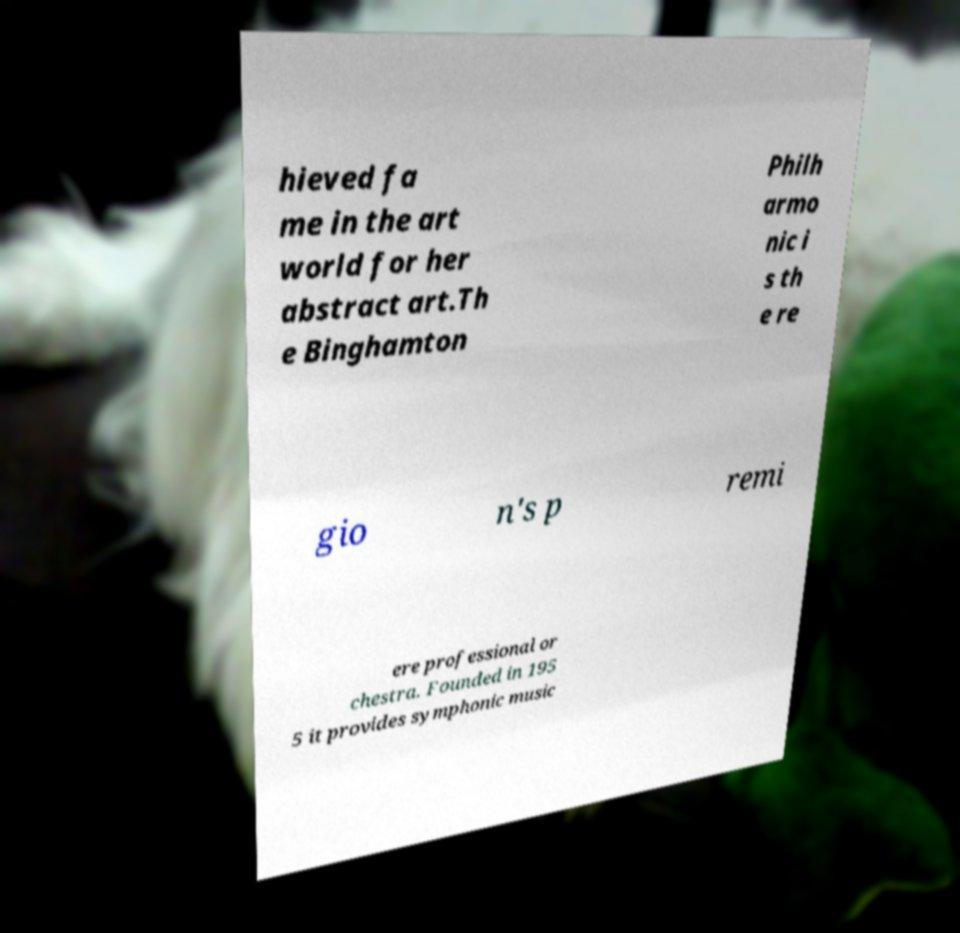Can you read and provide the text displayed in the image?This photo seems to have some interesting text. Can you extract and type it out for me? hieved fa me in the art world for her abstract art.Th e Binghamton Philh armo nic i s th e re gio n's p remi ere professional or chestra. Founded in 195 5 it provides symphonic music 